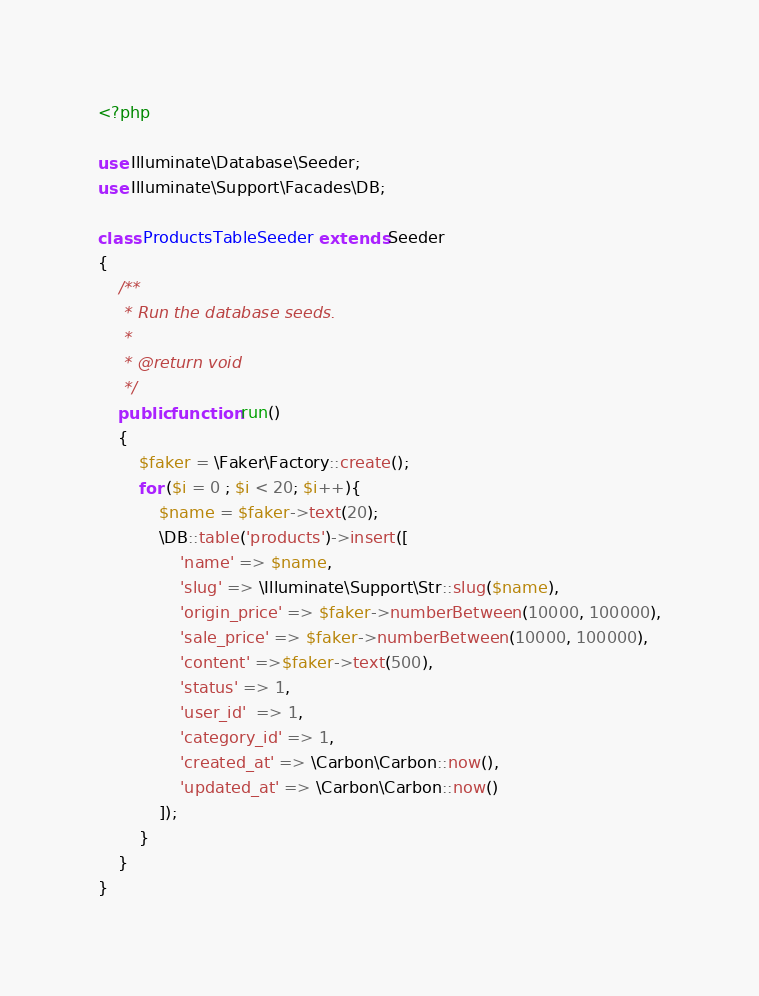<code> <loc_0><loc_0><loc_500><loc_500><_PHP_><?php

use Illuminate\Database\Seeder;
use Illuminate\Support\Facades\DB;

class ProductsTableSeeder extends Seeder
{
    /**
     * Run the database seeds.
     *
     * @return void
     */
    public function run()
    {
        $faker = \Faker\Factory::create();
        for ($i = 0 ; $i < 20; $i++){
        	$name = $faker->text(20);
            \DB::table('products')->insert([
                'name' => $name,
                'slug' => \Illuminate\Support\Str::slug($name),
                'origin_price' => $faker->numberBetween(10000, 100000),
                'sale_price' => $faker->numberBetween(10000, 100000),
                'content' =>$faker->text(500),
                'status' => 1, 
                'user_id'  => 1,
                'category_id' => 1,
                'created_at' => \Carbon\Carbon::now(),
	        	'updated_at' => \Carbon\Carbon::now()
            ]);
        }
    }
}
</code> 